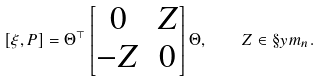<formula> <loc_0><loc_0><loc_500><loc_500>[ \xi , P ] = \Theta ^ { \top } \begin{bmatrix} 0 & Z \\ - Z & 0 \end{bmatrix} \Theta , \quad Z \in \S y m _ { n } .</formula> 